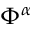Convert formula to latex. <formula><loc_0><loc_0><loc_500><loc_500>\Phi ^ { \alpha }</formula> 